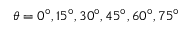<formula> <loc_0><loc_0><loc_500><loc_500>\theta = 0 ^ { \circ } , 1 5 ^ { \circ } , 3 0 ^ { \circ } , 4 5 ^ { \circ } , 6 0 ^ { \circ } , 7 5 ^ { \circ }</formula> 